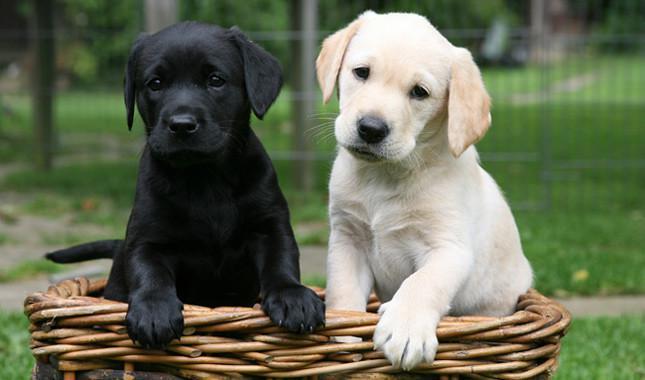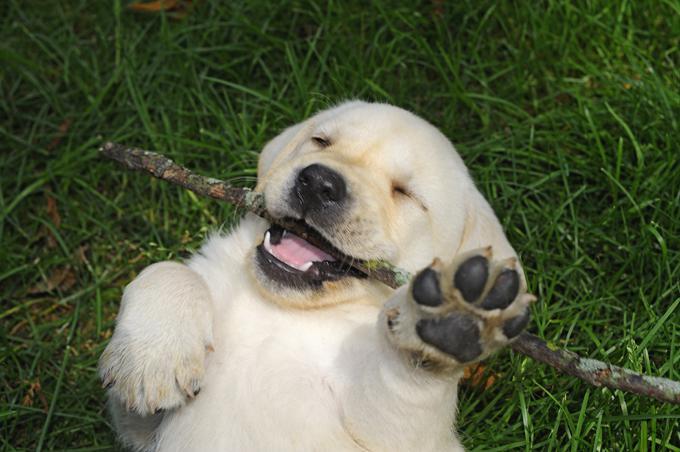The first image is the image on the left, the second image is the image on the right. Given the left and right images, does the statement "There are exactly two dogs in the left image." hold true? Answer yes or no. Yes. The first image is the image on the left, the second image is the image on the right. Analyze the images presented: Is the assertion "At least one dog has a green tennis ball." valid? Answer yes or no. No. 